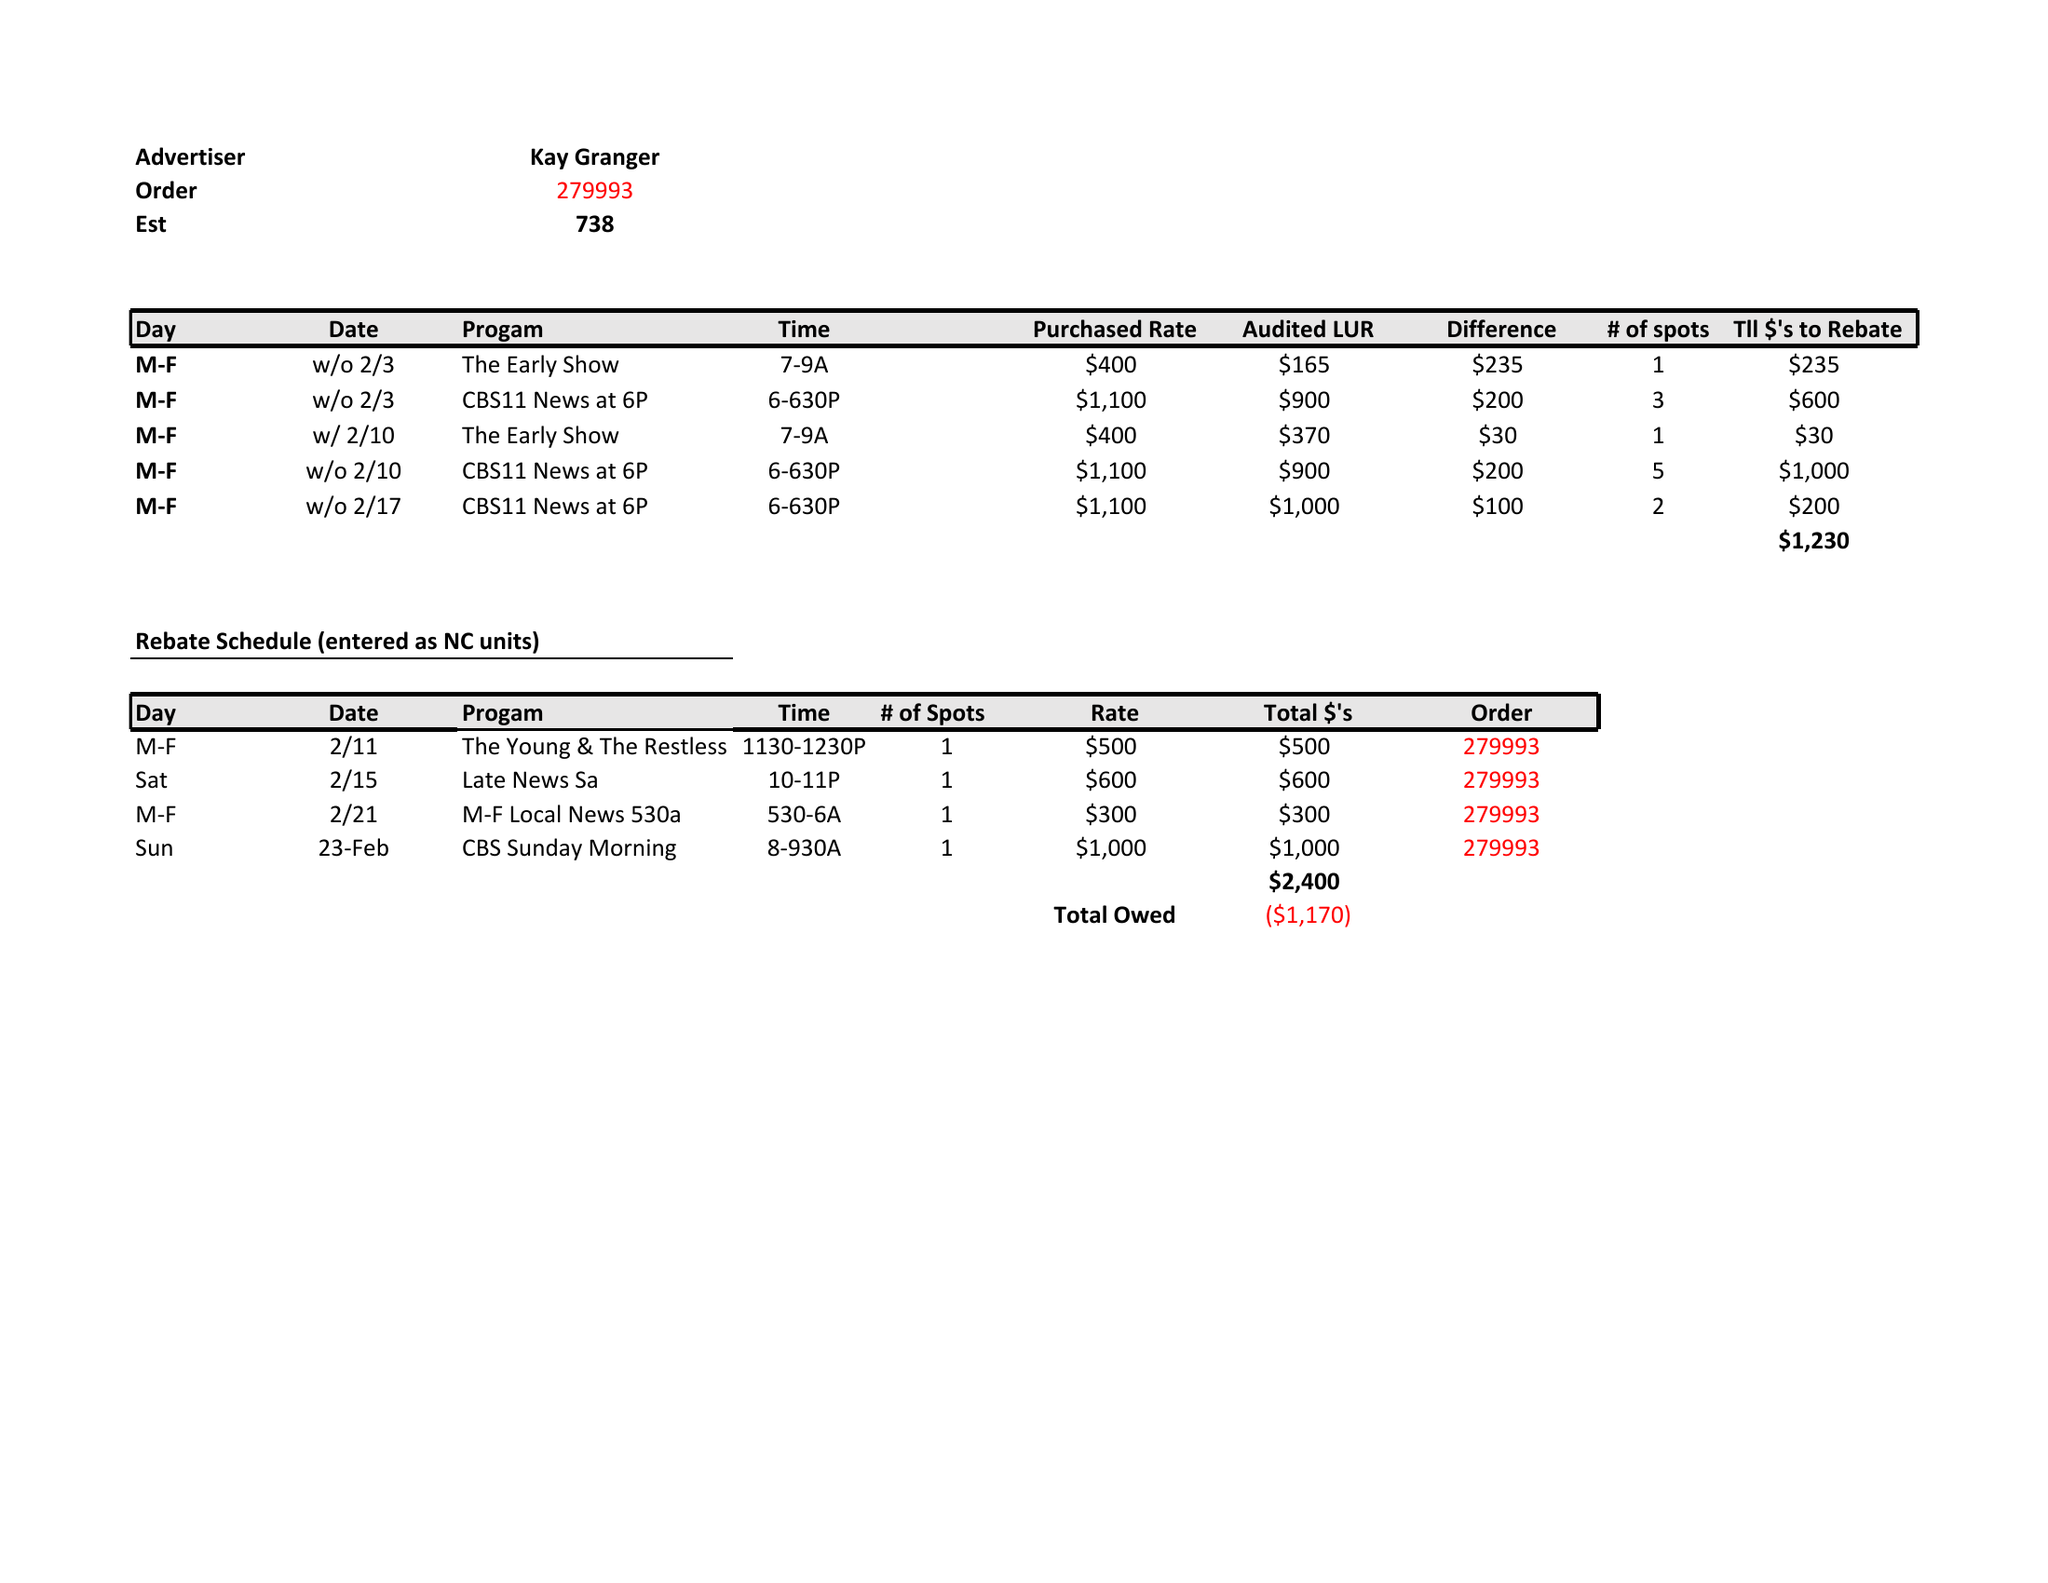What is the value for the flight_from?
Answer the question using a single word or phrase. None 